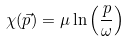Convert formula to latex. <formula><loc_0><loc_0><loc_500><loc_500>\chi ( \vec { p } ) = \mu \ln \left ( \frac { p } { \omega } \right )</formula> 